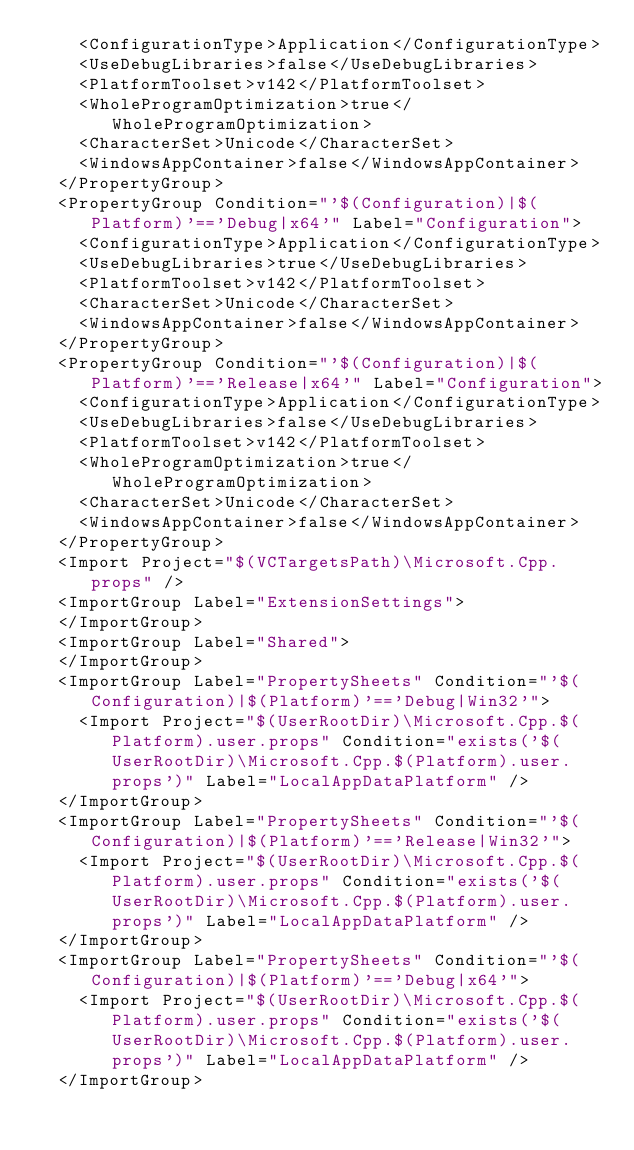<code> <loc_0><loc_0><loc_500><loc_500><_XML_>    <ConfigurationType>Application</ConfigurationType>
    <UseDebugLibraries>false</UseDebugLibraries>
    <PlatformToolset>v142</PlatformToolset>
    <WholeProgramOptimization>true</WholeProgramOptimization>
    <CharacterSet>Unicode</CharacterSet>
    <WindowsAppContainer>false</WindowsAppContainer>
  </PropertyGroup>
  <PropertyGroup Condition="'$(Configuration)|$(Platform)'=='Debug|x64'" Label="Configuration">
    <ConfigurationType>Application</ConfigurationType>
    <UseDebugLibraries>true</UseDebugLibraries>
    <PlatformToolset>v142</PlatformToolset>
    <CharacterSet>Unicode</CharacterSet>
    <WindowsAppContainer>false</WindowsAppContainer>
  </PropertyGroup>
  <PropertyGroup Condition="'$(Configuration)|$(Platform)'=='Release|x64'" Label="Configuration">
    <ConfigurationType>Application</ConfigurationType>
    <UseDebugLibraries>false</UseDebugLibraries>
    <PlatformToolset>v142</PlatformToolset>
    <WholeProgramOptimization>true</WholeProgramOptimization>
    <CharacterSet>Unicode</CharacterSet>
    <WindowsAppContainer>false</WindowsAppContainer>
  </PropertyGroup>
  <Import Project="$(VCTargetsPath)\Microsoft.Cpp.props" />
  <ImportGroup Label="ExtensionSettings">
  </ImportGroup>
  <ImportGroup Label="Shared">
  </ImportGroup>
  <ImportGroup Label="PropertySheets" Condition="'$(Configuration)|$(Platform)'=='Debug|Win32'">
    <Import Project="$(UserRootDir)\Microsoft.Cpp.$(Platform).user.props" Condition="exists('$(UserRootDir)\Microsoft.Cpp.$(Platform).user.props')" Label="LocalAppDataPlatform" />
  </ImportGroup>
  <ImportGroup Label="PropertySheets" Condition="'$(Configuration)|$(Platform)'=='Release|Win32'">
    <Import Project="$(UserRootDir)\Microsoft.Cpp.$(Platform).user.props" Condition="exists('$(UserRootDir)\Microsoft.Cpp.$(Platform).user.props')" Label="LocalAppDataPlatform" />
  </ImportGroup>
  <ImportGroup Label="PropertySheets" Condition="'$(Configuration)|$(Platform)'=='Debug|x64'">
    <Import Project="$(UserRootDir)\Microsoft.Cpp.$(Platform).user.props" Condition="exists('$(UserRootDir)\Microsoft.Cpp.$(Platform).user.props')" Label="LocalAppDataPlatform" />
  </ImportGroup></code> 